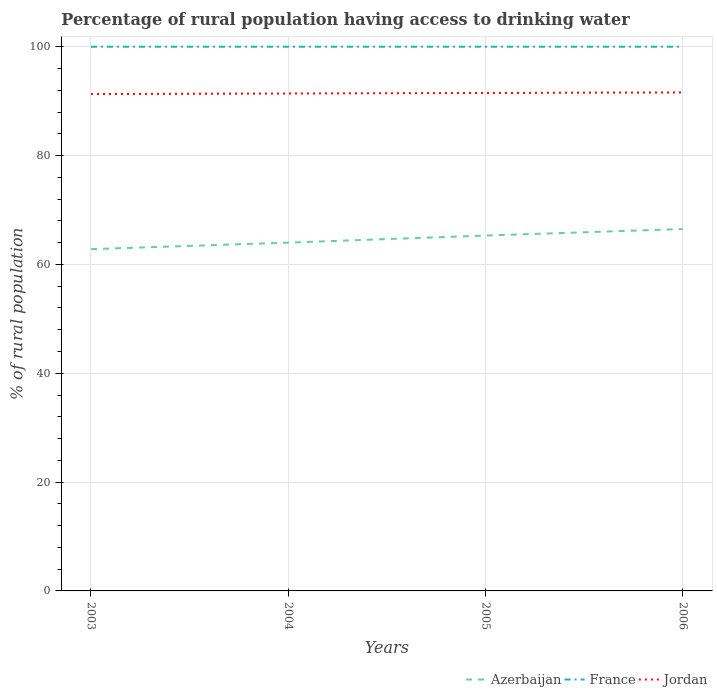How many different coloured lines are there?
Provide a succinct answer. 3. Does the line corresponding to France intersect with the line corresponding to Jordan?
Make the answer very short. No. Is the number of lines equal to the number of legend labels?
Your answer should be compact. Yes. Across all years, what is the maximum percentage of rural population having access to drinking water in France?
Your response must be concise. 100. In which year was the percentage of rural population having access to drinking water in France maximum?
Give a very brief answer. 2003. What is the total percentage of rural population having access to drinking water in Azerbaijan in the graph?
Keep it short and to the point. -1.3. What is the difference between the highest and the lowest percentage of rural population having access to drinking water in Jordan?
Offer a very short reply. 2. Is the percentage of rural population having access to drinking water in France strictly greater than the percentage of rural population having access to drinking water in Jordan over the years?
Keep it short and to the point. No. What is the difference between two consecutive major ticks on the Y-axis?
Ensure brevity in your answer.  20. Are the values on the major ticks of Y-axis written in scientific E-notation?
Give a very brief answer. No. Does the graph contain grids?
Ensure brevity in your answer.  Yes. Where does the legend appear in the graph?
Your answer should be compact. Bottom right. How many legend labels are there?
Your response must be concise. 3. How are the legend labels stacked?
Provide a short and direct response. Horizontal. What is the title of the graph?
Offer a terse response. Percentage of rural population having access to drinking water. Does "Puerto Rico" appear as one of the legend labels in the graph?
Offer a terse response. No. What is the label or title of the Y-axis?
Your answer should be very brief. % of rural population. What is the % of rural population of Azerbaijan in 2003?
Make the answer very short. 62.8. What is the % of rural population of France in 2003?
Provide a short and direct response. 100. What is the % of rural population of Jordan in 2003?
Your answer should be very brief. 91.3. What is the % of rural population of Azerbaijan in 2004?
Your response must be concise. 64. What is the % of rural population in France in 2004?
Give a very brief answer. 100. What is the % of rural population in Jordan in 2004?
Make the answer very short. 91.4. What is the % of rural population in Azerbaijan in 2005?
Offer a terse response. 65.3. What is the % of rural population in Jordan in 2005?
Provide a succinct answer. 91.5. What is the % of rural population in Azerbaijan in 2006?
Offer a very short reply. 66.5. What is the % of rural population of Jordan in 2006?
Offer a very short reply. 91.6. Across all years, what is the maximum % of rural population in Azerbaijan?
Keep it short and to the point. 66.5. Across all years, what is the maximum % of rural population in France?
Provide a short and direct response. 100. Across all years, what is the maximum % of rural population in Jordan?
Provide a succinct answer. 91.6. Across all years, what is the minimum % of rural population of Azerbaijan?
Make the answer very short. 62.8. Across all years, what is the minimum % of rural population in Jordan?
Provide a short and direct response. 91.3. What is the total % of rural population in Azerbaijan in the graph?
Your answer should be very brief. 258.6. What is the total % of rural population of Jordan in the graph?
Offer a terse response. 365.8. What is the difference between the % of rural population in Azerbaijan in 2003 and that in 2004?
Make the answer very short. -1.2. What is the difference between the % of rural population of France in 2003 and that in 2004?
Your response must be concise. 0. What is the difference between the % of rural population in Azerbaijan in 2003 and that in 2005?
Give a very brief answer. -2.5. What is the difference between the % of rural population in France in 2003 and that in 2005?
Keep it short and to the point. 0. What is the difference between the % of rural population in Jordan in 2003 and that in 2005?
Your answer should be very brief. -0.2. What is the difference between the % of rural population of Azerbaijan in 2003 and that in 2006?
Offer a very short reply. -3.7. What is the difference between the % of rural population in France in 2003 and that in 2006?
Offer a very short reply. 0. What is the difference between the % of rural population of Azerbaijan in 2004 and that in 2005?
Give a very brief answer. -1.3. What is the difference between the % of rural population in Jordan in 2004 and that in 2005?
Your answer should be very brief. -0.1. What is the difference between the % of rural population of Azerbaijan in 2004 and that in 2006?
Provide a succinct answer. -2.5. What is the difference between the % of rural population of France in 2004 and that in 2006?
Make the answer very short. 0. What is the difference between the % of rural population in France in 2005 and that in 2006?
Offer a very short reply. 0. What is the difference between the % of rural population of Azerbaijan in 2003 and the % of rural population of France in 2004?
Offer a terse response. -37.2. What is the difference between the % of rural population in Azerbaijan in 2003 and the % of rural population in Jordan in 2004?
Provide a succinct answer. -28.6. What is the difference between the % of rural population in Azerbaijan in 2003 and the % of rural population in France in 2005?
Provide a short and direct response. -37.2. What is the difference between the % of rural population in Azerbaijan in 2003 and the % of rural population in Jordan in 2005?
Your answer should be very brief. -28.7. What is the difference between the % of rural population of Azerbaijan in 2003 and the % of rural population of France in 2006?
Your answer should be compact. -37.2. What is the difference between the % of rural population of Azerbaijan in 2003 and the % of rural population of Jordan in 2006?
Ensure brevity in your answer.  -28.8. What is the difference between the % of rural population of Azerbaijan in 2004 and the % of rural population of France in 2005?
Your answer should be compact. -36. What is the difference between the % of rural population of Azerbaijan in 2004 and the % of rural population of Jordan in 2005?
Your answer should be compact. -27.5. What is the difference between the % of rural population in France in 2004 and the % of rural population in Jordan in 2005?
Offer a very short reply. 8.5. What is the difference between the % of rural population of Azerbaijan in 2004 and the % of rural population of France in 2006?
Your response must be concise. -36. What is the difference between the % of rural population of Azerbaijan in 2004 and the % of rural population of Jordan in 2006?
Provide a succinct answer. -27.6. What is the difference between the % of rural population of France in 2004 and the % of rural population of Jordan in 2006?
Your answer should be compact. 8.4. What is the difference between the % of rural population of Azerbaijan in 2005 and the % of rural population of France in 2006?
Your answer should be compact. -34.7. What is the difference between the % of rural population in Azerbaijan in 2005 and the % of rural population in Jordan in 2006?
Keep it short and to the point. -26.3. What is the difference between the % of rural population of France in 2005 and the % of rural population of Jordan in 2006?
Provide a short and direct response. 8.4. What is the average % of rural population in Azerbaijan per year?
Give a very brief answer. 64.65. What is the average % of rural population of France per year?
Your response must be concise. 100. What is the average % of rural population in Jordan per year?
Offer a very short reply. 91.45. In the year 2003, what is the difference between the % of rural population in Azerbaijan and % of rural population in France?
Provide a short and direct response. -37.2. In the year 2003, what is the difference between the % of rural population of Azerbaijan and % of rural population of Jordan?
Ensure brevity in your answer.  -28.5. In the year 2003, what is the difference between the % of rural population of France and % of rural population of Jordan?
Keep it short and to the point. 8.7. In the year 2004, what is the difference between the % of rural population of Azerbaijan and % of rural population of France?
Your answer should be compact. -36. In the year 2004, what is the difference between the % of rural population in Azerbaijan and % of rural population in Jordan?
Your answer should be very brief. -27.4. In the year 2004, what is the difference between the % of rural population in France and % of rural population in Jordan?
Ensure brevity in your answer.  8.6. In the year 2005, what is the difference between the % of rural population in Azerbaijan and % of rural population in France?
Make the answer very short. -34.7. In the year 2005, what is the difference between the % of rural population in Azerbaijan and % of rural population in Jordan?
Keep it short and to the point. -26.2. In the year 2006, what is the difference between the % of rural population of Azerbaijan and % of rural population of France?
Provide a succinct answer. -33.5. In the year 2006, what is the difference between the % of rural population in Azerbaijan and % of rural population in Jordan?
Ensure brevity in your answer.  -25.1. What is the ratio of the % of rural population in Azerbaijan in 2003 to that in 2004?
Offer a terse response. 0.98. What is the ratio of the % of rural population of France in 2003 to that in 2004?
Ensure brevity in your answer.  1. What is the ratio of the % of rural population of Azerbaijan in 2003 to that in 2005?
Provide a short and direct response. 0.96. What is the ratio of the % of rural population of France in 2003 to that in 2005?
Ensure brevity in your answer.  1. What is the ratio of the % of rural population in Jordan in 2003 to that in 2005?
Make the answer very short. 1. What is the ratio of the % of rural population in France in 2003 to that in 2006?
Your answer should be compact. 1. What is the ratio of the % of rural population of Azerbaijan in 2004 to that in 2005?
Offer a terse response. 0.98. What is the ratio of the % of rural population of Jordan in 2004 to that in 2005?
Your answer should be compact. 1. What is the ratio of the % of rural population in Azerbaijan in 2004 to that in 2006?
Provide a succinct answer. 0.96. What is the ratio of the % of rural population in France in 2004 to that in 2006?
Your response must be concise. 1. What is the ratio of the % of rural population of Jordan in 2004 to that in 2006?
Provide a short and direct response. 1. What is the ratio of the % of rural population in Azerbaijan in 2005 to that in 2006?
Offer a very short reply. 0.98. What is the ratio of the % of rural population in France in 2005 to that in 2006?
Ensure brevity in your answer.  1. What is the difference between the highest and the second highest % of rural population of Azerbaijan?
Your answer should be compact. 1.2. What is the difference between the highest and the second highest % of rural population of France?
Your response must be concise. 0. What is the difference between the highest and the lowest % of rural population of Azerbaijan?
Ensure brevity in your answer.  3.7. 